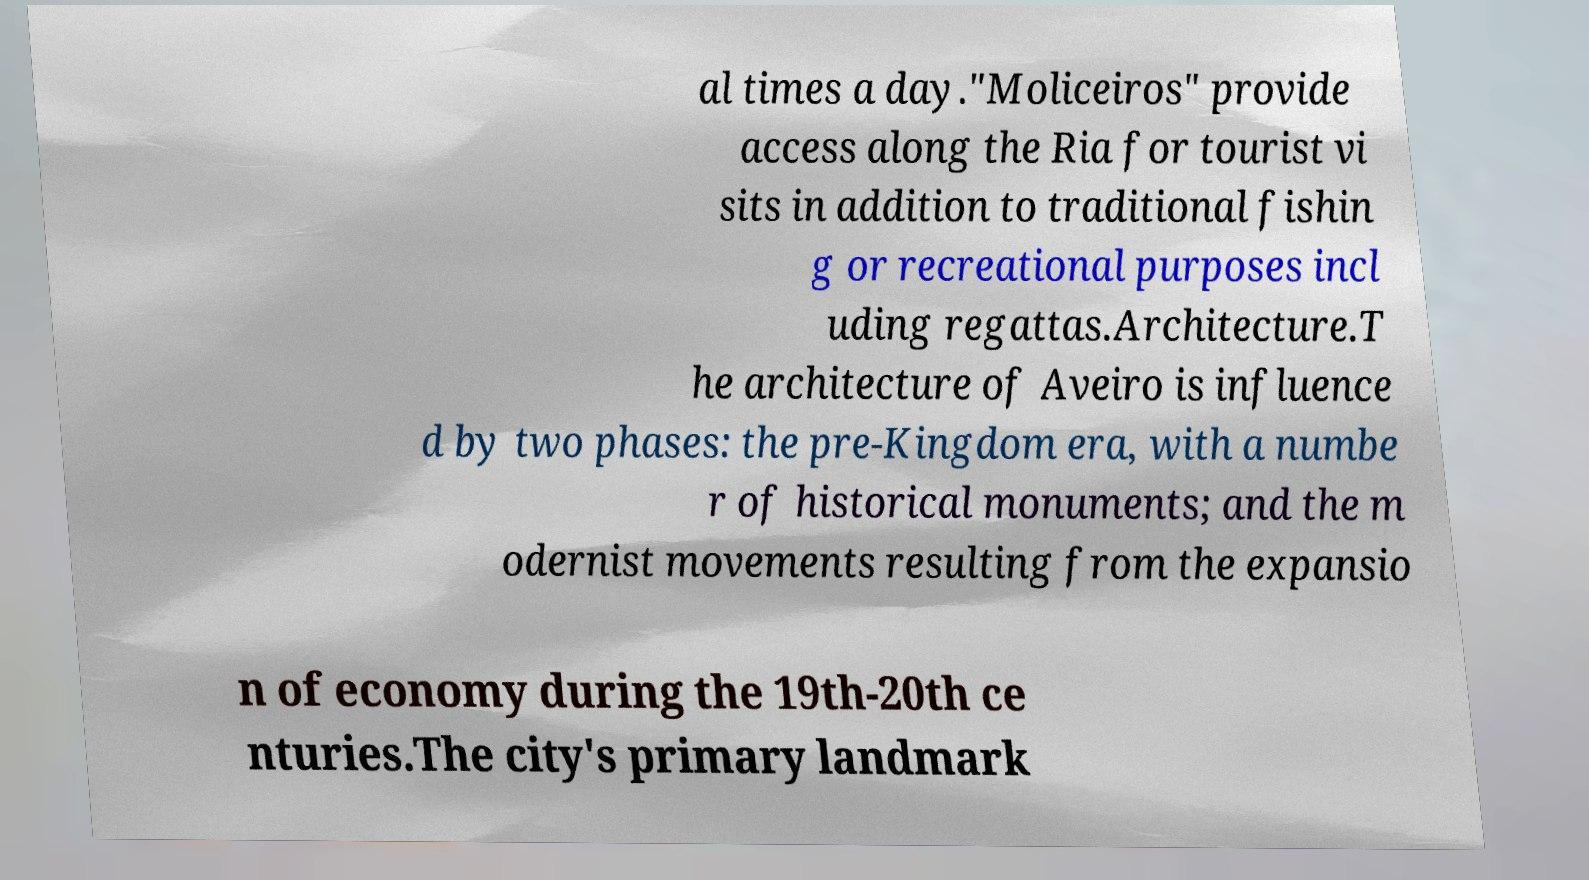Could you assist in decoding the text presented in this image and type it out clearly? al times a day."Moliceiros" provide access along the Ria for tourist vi sits in addition to traditional fishin g or recreational purposes incl uding regattas.Architecture.T he architecture of Aveiro is influence d by two phases: the pre-Kingdom era, with a numbe r of historical monuments; and the m odernist movements resulting from the expansio n of economy during the 19th-20th ce nturies.The city's primary landmark 